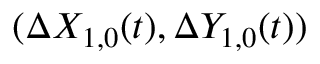<formula> <loc_0><loc_0><loc_500><loc_500>( \Delta X _ { 1 , 0 } ( t ) , \Delta Y _ { 1 , 0 } ( t ) )</formula> 